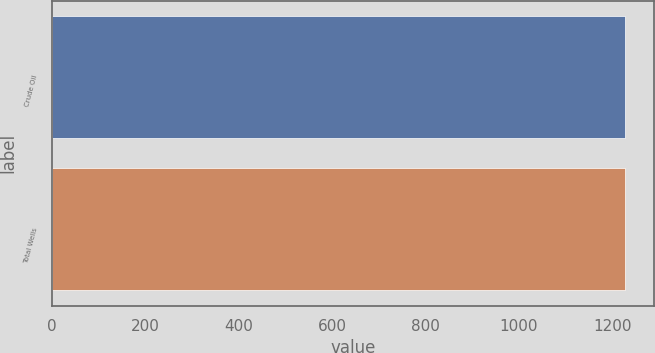Convert chart to OTSL. <chart><loc_0><loc_0><loc_500><loc_500><bar_chart><fcel>Crude Oil<fcel>Total Wells<nl><fcel>1227<fcel>1227.1<nl></chart> 